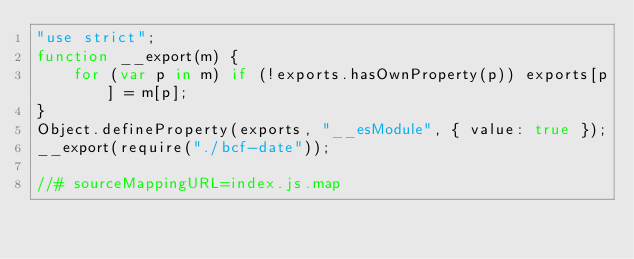<code> <loc_0><loc_0><loc_500><loc_500><_JavaScript_>"use strict";
function __export(m) {
    for (var p in m) if (!exports.hasOwnProperty(p)) exports[p] = m[p];
}
Object.defineProperty(exports, "__esModule", { value: true });
__export(require("./bcf-date"));

//# sourceMappingURL=index.js.map
</code> 